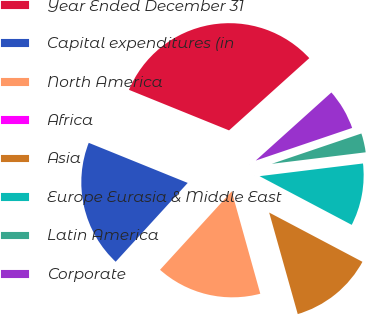<chart> <loc_0><loc_0><loc_500><loc_500><pie_chart><fcel>Year Ended December 31<fcel>Capital expenditures (in<fcel>North America<fcel>Africa<fcel>Asia<fcel>Europe Eurasia & Middle East<fcel>Latin America<fcel>Corporate<nl><fcel>32.21%<fcel>19.34%<fcel>16.12%<fcel>0.03%<fcel>12.9%<fcel>9.68%<fcel>3.25%<fcel>6.47%<nl></chart> 